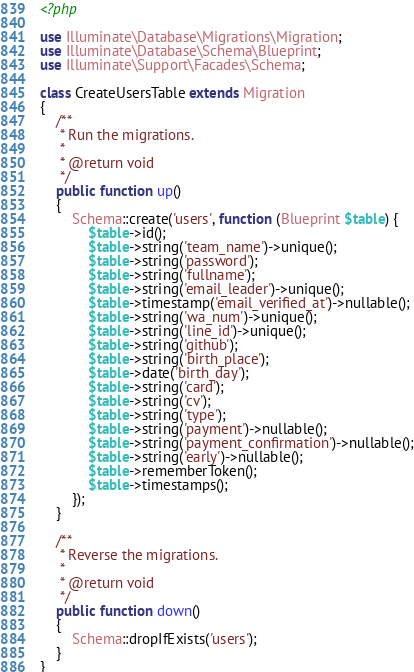Convert code to text. <code><loc_0><loc_0><loc_500><loc_500><_PHP_><?php

use Illuminate\Database\Migrations\Migration;
use Illuminate\Database\Schema\Blueprint;
use Illuminate\Support\Facades\Schema;

class CreateUsersTable extends Migration
{
    /**
     * Run the migrations.
     *
     * @return void
     */
    public function up()
    {
        Schema::create('users', function (Blueprint $table) {
            $table->id();
            $table->string('team_name')->unique();
            $table->string('password');
            $table->string('fullname');
            $table->string('email_leader')->unique();
            $table->timestamp('email_verified_at')->nullable();
            $table->string('wa_num')->unique();
            $table->string('line_id')->unique();
            $table->string('github');
            $table->string('birth_place');
            $table->date('birth_day');
            $table->string('card');
            $table->string('cv');
            $table->string('type');
            $table->string('payment')->nullable();
            $table->string('payment_confirmation')->nullable();
            $table->string('early')->nullable();
            $table->rememberToken();
            $table->timestamps();
        });
    }

    /**
     * Reverse the migrations.
     *
     * @return void
     */
    public function down()
    {
        Schema::dropIfExists('users');
    }
}
</code> 